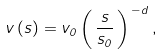<formula> <loc_0><loc_0><loc_500><loc_500>v \, ( s ) = v _ { 0 } \left ( \, \frac { s } { s _ { 0 } } \, \right ) ^ { \, - d } ,</formula> 